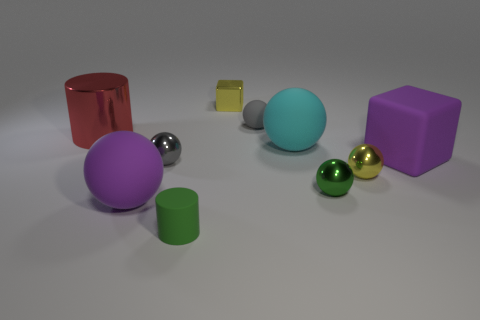Subtract all purple rubber spheres. How many spheres are left? 5 Subtract all purple balls. How many balls are left? 5 Subtract all purple spheres. Subtract all yellow blocks. How many spheres are left? 5 Subtract all cylinders. How many objects are left? 8 Add 4 big red metallic cylinders. How many big red metallic cylinders exist? 5 Subtract 0 cyan cylinders. How many objects are left? 10 Subtract all red matte balls. Subtract all large rubber things. How many objects are left? 7 Add 1 large cyan balls. How many large cyan balls are left? 2 